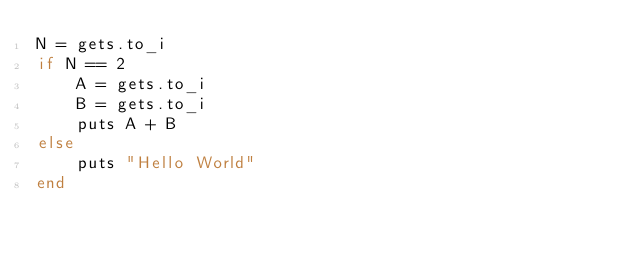<code> <loc_0><loc_0><loc_500><loc_500><_Ruby_>N = gets.to_i
if N == 2
    A = gets.to_i
    B = gets.to_i
    puts A + B
else
    puts "Hello World"
end</code> 